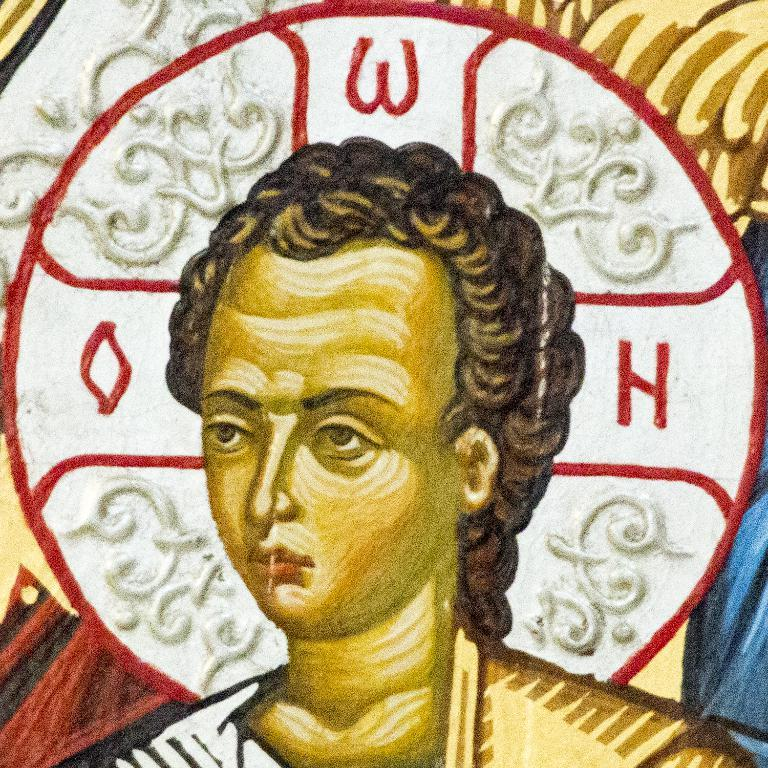What is depicted in the image? There is a painting of a person in the image. Can you describe the background of the painting? There is a design in the background of the painting. What type of pencil is the doctor using in the image? There is no doctor or pencil present in the image; it features a painting of a person with a design in the background. 